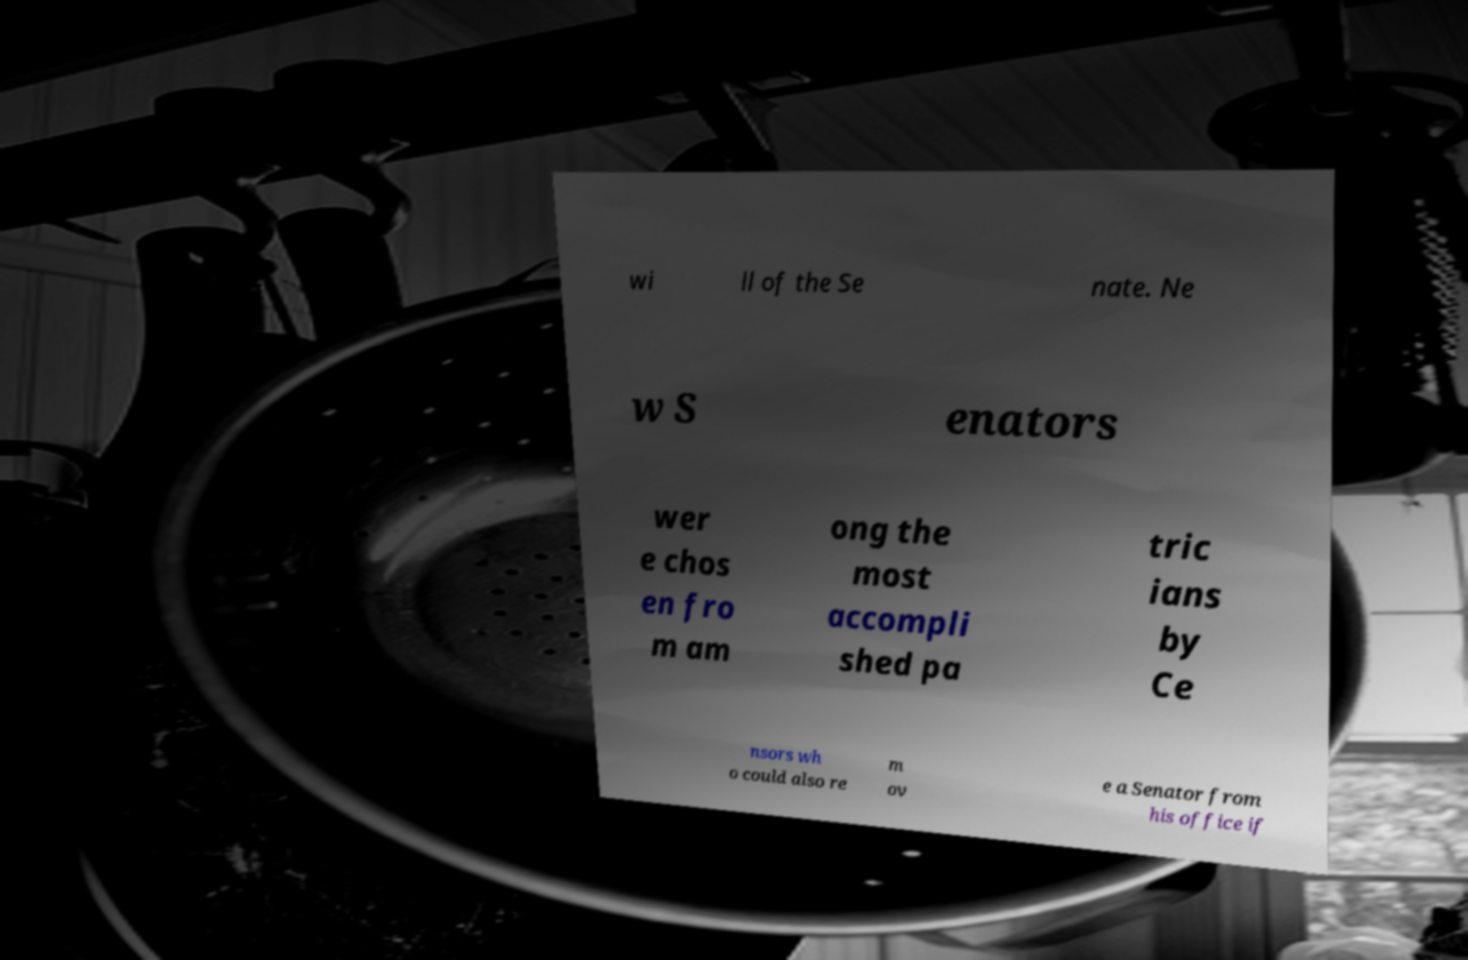Could you assist in decoding the text presented in this image and type it out clearly? wi ll of the Se nate. Ne w S enators wer e chos en fro m am ong the most accompli shed pa tric ians by Ce nsors wh o could also re m ov e a Senator from his office if 